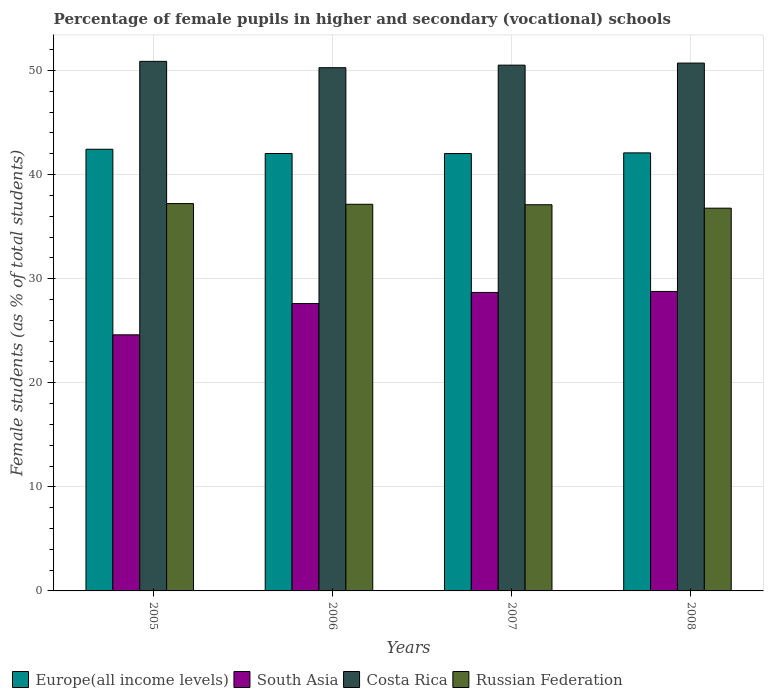How many different coloured bars are there?
Your answer should be very brief. 4. How many groups of bars are there?
Your answer should be very brief. 4. How many bars are there on the 4th tick from the left?
Offer a very short reply. 4. What is the label of the 1st group of bars from the left?
Provide a short and direct response. 2005. In how many cases, is the number of bars for a given year not equal to the number of legend labels?
Keep it short and to the point. 0. What is the percentage of female pupils in higher and secondary schools in Russian Federation in 2007?
Keep it short and to the point. 37.1. Across all years, what is the maximum percentage of female pupils in higher and secondary schools in Europe(all income levels)?
Your answer should be very brief. 42.43. Across all years, what is the minimum percentage of female pupils in higher and secondary schools in Costa Rica?
Offer a very short reply. 50.27. What is the total percentage of female pupils in higher and secondary schools in South Asia in the graph?
Ensure brevity in your answer.  109.66. What is the difference between the percentage of female pupils in higher and secondary schools in Costa Rica in 2005 and that in 2008?
Your response must be concise. 0.17. What is the difference between the percentage of female pupils in higher and secondary schools in Europe(all income levels) in 2007 and the percentage of female pupils in higher and secondary schools in Russian Federation in 2005?
Offer a terse response. 4.81. What is the average percentage of female pupils in higher and secondary schools in Costa Rica per year?
Give a very brief answer. 50.59. In the year 2006, what is the difference between the percentage of female pupils in higher and secondary schools in Russian Federation and percentage of female pupils in higher and secondary schools in South Asia?
Make the answer very short. 9.54. In how many years, is the percentage of female pupils in higher and secondary schools in Europe(all income levels) greater than 6 %?
Your response must be concise. 4. What is the ratio of the percentage of female pupils in higher and secondary schools in Russian Federation in 2005 to that in 2006?
Provide a short and direct response. 1. What is the difference between the highest and the second highest percentage of female pupils in higher and secondary schools in South Asia?
Provide a succinct answer. 0.1. What is the difference between the highest and the lowest percentage of female pupils in higher and secondary schools in Costa Rica?
Make the answer very short. 0.61. In how many years, is the percentage of female pupils in higher and secondary schools in Europe(all income levels) greater than the average percentage of female pupils in higher and secondary schools in Europe(all income levels) taken over all years?
Your response must be concise. 1. Is it the case that in every year, the sum of the percentage of female pupils in higher and secondary schools in Russian Federation and percentage of female pupils in higher and secondary schools in Europe(all income levels) is greater than the sum of percentage of female pupils in higher and secondary schools in South Asia and percentage of female pupils in higher and secondary schools in Costa Rica?
Ensure brevity in your answer.  Yes. What does the 1st bar from the right in 2005 represents?
Keep it short and to the point. Russian Federation. Is it the case that in every year, the sum of the percentage of female pupils in higher and secondary schools in Europe(all income levels) and percentage of female pupils in higher and secondary schools in Russian Federation is greater than the percentage of female pupils in higher and secondary schools in Costa Rica?
Offer a very short reply. Yes. How many bars are there?
Offer a terse response. 16. Are all the bars in the graph horizontal?
Offer a terse response. No. How many years are there in the graph?
Ensure brevity in your answer.  4. What is the difference between two consecutive major ticks on the Y-axis?
Provide a succinct answer. 10. Are the values on the major ticks of Y-axis written in scientific E-notation?
Make the answer very short. No. Does the graph contain any zero values?
Your answer should be compact. No. How are the legend labels stacked?
Make the answer very short. Horizontal. What is the title of the graph?
Provide a short and direct response. Percentage of female pupils in higher and secondary (vocational) schools. What is the label or title of the X-axis?
Your response must be concise. Years. What is the label or title of the Y-axis?
Offer a very short reply. Female students (as % of total students). What is the Female students (as % of total students) of Europe(all income levels) in 2005?
Offer a very short reply. 42.43. What is the Female students (as % of total students) in South Asia in 2005?
Give a very brief answer. 24.6. What is the Female students (as % of total students) in Costa Rica in 2005?
Keep it short and to the point. 50.88. What is the Female students (as % of total students) of Russian Federation in 2005?
Ensure brevity in your answer.  37.21. What is the Female students (as % of total students) in Europe(all income levels) in 2006?
Your answer should be compact. 42.03. What is the Female students (as % of total students) of South Asia in 2006?
Give a very brief answer. 27.61. What is the Female students (as % of total students) in Costa Rica in 2006?
Your answer should be very brief. 50.27. What is the Female students (as % of total students) in Russian Federation in 2006?
Your answer should be very brief. 37.15. What is the Female students (as % of total students) in Europe(all income levels) in 2007?
Your answer should be very brief. 42.02. What is the Female students (as % of total students) in South Asia in 2007?
Provide a short and direct response. 28.68. What is the Female students (as % of total students) of Costa Rica in 2007?
Make the answer very short. 50.52. What is the Female students (as % of total students) of Russian Federation in 2007?
Offer a terse response. 37.1. What is the Female students (as % of total students) in Europe(all income levels) in 2008?
Your response must be concise. 42.09. What is the Female students (as % of total students) of South Asia in 2008?
Your answer should be very brief. 28.77. What is the Female students (as % of total students) of Costa Rica in 2008?
Provide a short and direct response. 50.71. What is the Female students (as % of total students) in Russian Federation in 2008?
Provide a short and direct response. 36.77. Across all years, what is the maximum Female students (as % of total students) in Europe(all income levels)?
Offer a terse response. 42.43. Across all years, what is the maximum Female students (as % of total students) in South Asia?
Your answer should be very brief. 28.77. Across all years, what is the maximum Female students (as % of total students) in Costa Rica?
Your answer should be compact. 50.88. Across all years, what is the maximum Female students (as % of total students) of Russian Federation?
Your answer should be very brief. 37.21. Across all years, what is the minimum Female students (as % of total students) of Europe(all income levels)?
Provide a short and direct response. 42.02. Across all years, what is the minimum Female students (as % of total students) of South Asia?
Offer a terse response. 24.6. Across all years, what is the minimum Female students (as % of total students) in Costa Rica?
Make the answer very short. 50.27. Across all years, what is the minimum Female students (as % of total students) of Russian Federation?
Provide a succinct answer. 36.77. What is the total Female students (as % of total students) in Europe(all income levels) in the graph?
Give a very brief answer. 168.57. What is the total Female students (as % of total students) of South Asia in the graph?
Your answer should be compact. 109.66. What is the total Female students (as % of total students) in Costa Rica in the graph?
Make the answer very short. 202.38. What is the total Female students (as % of total students) in Russian Federation in the graph?
Make the answer very short. 148.24. What is the difference between the Female students (as % of total students) of Europe(all income levels) in 2005 and that in 2006?
Your answer should be compact. 0.41. What is the difference between the Female students (as % of total students) of South Asia in 2005 and that in 2006?
Your response must be concise. -3.01. What is the difference between the Female students (as % of total students) in Costa Rica in 2005 and that in 2006?
Provide a succinct answer. 0.61. What is the difference between the Female students (as % of total students) in Russian Federation in 2005 and that in 2006?
Your answer should be compact. 0.07. What is the difference between the Female students (as % of total students) in Europe(all income levels) in 2005 and that in 2007?
Give a very brief answer. 0.41. What is the difference between the Female students (as % of total students) in South Asia in 2005 and that in 2007?
Offer a terse response. -4.07. What is the difference between the Female students (as % of total students) in Costa Rica in 2005 and that in 2007?
Your response must be concise. 0.36. What is the difference between the Female students (as % of total students) in Russian Federation in 2005 and that in 2007?
Your answer should be compact. 0.11. What is the difference between the Female students (as % of total students) in Europe(all income levels) in 2005 and that in 2008?
Your answer should be compact. 0.35. What is the difference between the Female students (as % of total students) of South Asia in 2005 and that in 2008?
Give a very brief answer. -4.17. What is the difference between the Female students (as % of total students) of Costa Rica in 2005 and that in 2008?
Your answer should be compact. 0.17. What is the difference between the Female students (as % of total students) in Russian Federation in 2005 and that in 2008?
Ensure brevity in your answer.  0.44. What is the difference between the Female students (as % of total students) in Europe(all income levels) in 2006 and that in 2007?
Offer a terse response. 0. What is the difference between the Female students (as % of total students) in South Asia in 2006 and that in 2007?
Your response must be concise. -1.07. What is the difference between the Female students (as % of total students) of Costa Rica in 2006 and that in 2007?
Offer a terse response. -0.25. What is the difference between the Female students (as % of total students) of Russian Federation in 2006 and that in 2007?
Ensure brevity in your answer.  0.05. What is the difference between the Female students (as % of total students) of Europe(all income levels) in 2006 and that in 2008?
Ensure brevity in your answer.  -0.06. What is the difference between the Female students (as % of total students) of South Asia in 2006 and that in 2008?
Offer a terse response. -1.16. What is the difference between the Female students (as % of total students) of Costa Rica in 2006 and that in 2008?
Offer a terse response. -0.44. What is the difference between the Female students (as % of total students) in Russian Federation in 2006 and that in 2008?
Your answer should be very brief. 0.38. What is the difference between the Female students (as % of total students) in Europe(all income levels) in 2007 and that in 2008?
Provide a short and direct response. -0.06. What is the difference between the Female students (as % of total students) in South Asia in 2007 and that in 2008?
Provide a succinct answer. -0.1. What is the difference between the Female students (as % of total students) of Costa Rica in 2007 and that in 2008?
Your answer should be very brief. -0.2. What is the difference between the Female students (as % of total students) of Russian Federation in 2007 and that in 2008?
Provide a succinct answer. 0.33. What is the difference between the Female students (as % of total students) in Europe(all income levels) in 2005 and the Female students (as % of total students) in South Asia in 2006?
Offer a terse response. 14.82. What is the difference between the Female students (as % of total students) of Europe(all income levels) in 2005 and the Female students (as % of total students) of Costa Rica in 2006?
Make the answer very short. -7.84. What is the difference between the Female students (as % of total students) of Europe(all income levels) in 2005 and the Female students (as % of total students) of Russian Federation in 2006?
Keep it short and to the point. 5.29. What is the difference between the Female students (as % of total students) of South Asia in 2005 and the Female students (as % of total students) of Costa Rica in 2006?
Give a very brief answer. -25.66. What is the difference between the Female students (as % of total students) in South Asia in 2005 and the Female students (as % of total students) in Russian Federation in 2006?
Ensure brevity in your answer.  -12.54. What is the difference between the Female students (as % of total students) of Costa Rica in 2005 and the Female students (as % of total students) of Russian Federation in 2006?
Ensure brevity in your answer.  13.73. What is the difference between the Female students (as % of total students) in Europe(all income levels) in 2005 and the Female students (as % of total students) in South Asia in 2007?
Provide a succinct answer. 13.76. What is the difference between the Female students (as % of total students) of Europe(all income levels) in 2005 and the Female students (as % of total students) of Costa Rica in 2007?
Keep it short and to the point. -8.08. What is the difference between the Female students (as % of total students) of Europe(all income levels) in 2005 and the Female students (as % of total students) of Russian Federation in 2007?
Provide a short and direct response. 5.33. What is the difference between the Female students (as % of total students) of South Asia in 2005 and the Female students (as % of total students) of Costa Rica in 2007?
Offer a very short reply. -25.91. What is the difference between the Female students (as % of total students) of South Asia in 2005 and the Female students (as % of total students) of Russian Federation in 2007?
Provide a succinct answer. -12.5. What is the difference between the Female students (as % of total students) of Costa Rica in 2005 and the Female students (as % of total students) of Russian Federation in 2007?
Your answer should be compact. 13.78. What is the difference between the Female students (as % of total students) in Europe(all income levels) in 2005 and the Female students (as % of total students) in South Asia in 2008?
Provide a short and direct response. 13.66. What is the difference between the Female students (as % of total students) in Europe(all income levels) in 2005 and the Female students (as % of total students) in Costa Rica in 2008?
Your answer should be very brief. -8.28. What is the difference between the Female students (as % of total students) of Europe(all income levels) in 2005 and the Female students (as % of total students) of Russian Federation in 2008?
Make the answer very short. 5.66. What is the difference between the Female students (as % of total students) in South Asia in 2005 and the Female students (as % of total students) in Costa Rica in 2008?
Provide a succinct answer. -26.11. What is the difference between the Female students (as % of total students) of South Asia in 2005 and the Female students (as % of total students) of Russian Federation in 2008?
Your answer should be compact. -12.17. What is the difference between the Female students (as % of total students) in Costa Rica in 2005 and the Female students (as % of total students) in Russian Federation in 2008?
Offer a very short reply. 14.11. What is the difference between the Female students (as % of total students) in Europe(all income levels) in 2006 and the Female students (as % of total students) in South Asia in 2007?
Keep it short and to the point. 13.35. What is the difference between the Female students (as % of total students) in Europe(all income levels) in 2006 and the Female students (as % of total students) in Costa Rica in 2007?
Give a very brief answer. -8.49. What is the difference between the Female students (as % of total students) of Europe(all income levels) in 2006 and the Female students (as % of total students) of Russian Federation in 2007?
Ensure brevity in your answer.  4.92. What is the difference between the Female students (as % of total students) of South Asia in 2006 and the Female students (as % of total students) of Costa Rica in 2007?
Keep it short and to the point. -22.91. What is the difference between the Female students (as % of total students) of South Asia in 2006 and the Female students (as % of total students) of Russian Federation in 2007?
Ensure brevity in your answer.  -9.49. What is the difference between the Female students (as % of total students) in Costa Rica in 2006 and the Female students (as % of total students) in Russian Federation in 2007?
Provide a succinct answer. 13.17. What is the difference between the Female students (as % of total students) in Europe(all income levels) in 2006 and the Female students (as % of total students) in South Asia in 2008?
Your response must be concise. 13.25. What is the difference between the Female students (as % of total students) in Europe(all income levels) in 2006 and the Female students (as % of total students) in Costa Rica in 2008?
Keep it short and to the point. -8.69. What is the difference between the Female students (as % of total students) in Europe(all income levels) in 2006 and the Female students (as % of total students) in Russian Federation in 2008?
Give a very brief answer. 5.25. What is the difference between the Female students (as % of total students) in South Asia in 2006 and the Female students (as % of total students) in Costa Rica in 2008?
Provide a short and direct response. -23.1. What is the difference between the Female students (as % of total students) of South Asia in 2006 and the Female students (as % of total students) of Russian Federation in 2008?
Provide a succinct answer. -9.16. What is the difference between the Female students (as % of total students) in Costa Rica in 2006 and the Female students (as % of total students) in Russian Federation in 2008?
Your response must be concise. 13.5. What is the difference between the Female students (as % of total students) in Europe(all income levels) in 2007 and the Female students (as % of total students) in South Asia in 2008?
Offer a very short reply. 13.25. What is the difference between the Female students (as % of total students) in Europe(all income levels) in 2007 and the Female students (as % of total students) in Costa Rica in 2008?
Make the answer very short. -8.69. What is the difference between the Female students (as % of total students) of Europe(all income levels) in 2007 and the Female students (as % of total students) of Russian Federation in 2008?
Your response must be concise. 5.25. What is the difference between the Female students (as % of total students) in South Asia in 2007 and the Female students (as % of total students) in Costa Rica in 2008?
Give a very brief answer. -22.04. What is the difference between the Female students (as % of total students) of South Asia in 2007 and the Female students (as % of total students) of Russian Federation in 2008?
Offer a terse response. -8.1. What is the difference between the Female students (as % of total students) in Costa Rica in 2007 and the Female students (as % of total students) in Russian Federation in 2008?
Ensure brevity in your answer.  13.74. What is the average Female students (as % of total students) in Europe(all income levels) per year?
Give a very brief answer. 42.14. What is the average Female students (as % of total students) of South Asia per year?
Provide a succinct answer. 27.42. What is the average Female students (as % of total students) of Costa Rica per year?
Your answer should be compact. 50.59. What is the average Female students (as % of total students) of Russian Federation per year?
Your answer should be compact. 37.06. In the year 2005, what is the difference between the Female students (as % of total students) in Europe(all income levels) and Female students (as % of total students) in South Asia?
Your answer should be very brief. 17.83. In the year 2005, what is the difference between the Female students (as % of total students) of Europe(all income levels) and Female students (as % of total students) of Costa Rica?
Ensure brevity in your answer.  -8.45. In the year 2005, what is the difference between the Female students (as % of total students) in Europe(all income levels) and Female students (as % of total students) in Russian Federation?
Ensure brevity in your answer.  5.22. In the year 2005, what is the difference between the Female students (as % of total students) in South Asia and Female students (as % of total students) in Costa Rica?
Give a very brief answer. -26.27. In the year 2005, what is the difference between the Female students (as % of total students) of South Asia and Female students (as % of total students) of Russian Federation?
Your response must be concise. -12.61. In the year 2005, what is the difference between the Female students (as % of total students) of Costa Rica and Female students (as % of total students) of Russian Federation?
Keep it short and to the point. 13.66. In the year 2006, what is the difference between the Female students (as % of total students) of Europe(all income levels) and Female students (as % of total students) of South Asia?
Your answer should be very brief. 14.42. In the year 2006, what is the difference between the Female students (as % of total students) in Europe(all income levels) and Female students (as % of total students) in Costa Rica?
Offer a very short reply. -8.24. In the year 2006, what is the difference between the Female students (as % of total students) of Europe(all income levels) and Female students (as % of total students) of Russian Federation?
Give a very brief answer. 4.88. In the year 2006, what is the difference between the Female students (as % of total students) of South Asia and Female students (as % of total students) of Costa Rica?
Offer a very short reply. -22.66. In the year 2006, what is the difference between the Female students (as % of total students) in South Asia and Female students (as % of total students) in Russian Federation?
Your answer should be very brief. -9.54. In the year 2006, what is the difference between the Female students (as % of total students) in Costa Rica and Female students (as % of total students) in Russian Federation?
Provide a short and direct response. 13.12. In the year 2007, what is the difference between the Female students (as % of total students) in Europe(all income levels) and Female students (as % of total students) in South Asia?
Provide a succinct answer. 13.35. In the year 2007, what is the difference between the Female students (as % of total students) in Europe(all income levels) and Female students (as % of total students) in Costa Rica?
Offer a terse response. -8.49. In the year 2007, what is the difference between the Female students (as % of total students) in Europe(all income levels) and Female students (as % of total students) in Russian Federation?
Provide a succinct answer. 4.92. In the year 2007, what is the difference between the Female students (as % of total students) of South Asia and Female students (as % of total students) of Costa Rica?
Your response must be concise. -21.84. In the year 2007, what is the difference between the Female students (as % of total students) in South Asia and Female students (as % of total students) in Russian Federation?
Offer a terse response. -8.43. In the year 2007, what is the difference between the Female students (as % of total students) of Costa Rica and Female students (as % of total students) of Russian Federation?
Provide a short and direct response. 13.41. In the year 2008, what is the difference between the Female students (as % of total students) of Europe(all income levels) and Female students (as % of total students) of South Asia?
Your response must be concise. 13.31. In the year 2008, what is the difference between the Female students (as % of total students) in Europe(all income levels) and Female students (as % of total students) in Costa Rica?
Keep it short and to the point. -8.63. In the year 2008, what is the difference between the Female students (as % of total students) of Europe(all income levels) and Female students (as % of total students) of Russian Federation?
Give a very brief answer. 5.31. In the year 2008, what is the difference between the Female students (as % of total students) in South Asia and Female students (as % of total students) in Costa Rica?
Keep it short and to the point. -21.94. In the year 2008, what is the difference between the Female students (as % of total students) of South Asia and Female students (as % of total students) of Russian Federation?
Offer a terse response. -8. In the year 2008, what is the difference between the Female students (as % of total students) of Costa Rica and Female students (as % of total students) of Russian Federation?
Make the answer very short. 13.94. What is the ratio of the Female students (as % of total students) of Europe(all income levels) in 2005 to that in 2006?
Your answer should be very brief. 1.01. What is the ratio of the Female students (as % of total students) in South Asia in 2005 to that in 2006?
Your response must be concise. 0.89. What is the ratio of the Female students (as % of total students) of Costa Rica in 2005 to that in 2006?
Ensure brevity in your answer.  1.01. What is the ratio of the Female students (as % of total students) in Russian Federation in 2005 to that in 2006?
Your answer should be very brief. 1. What is the ratio of the Female students (as % of total students) of Europe(all income levels) in 2005 to that in 2007?
Offer a terse response. 1.01. What is the ratio of the Female students (as % of total students) in South Asia in 2005 to that in 2007?
Offer a terse response. 0.86. What is the ratio of the Female students (as % of total students) of Russian Federation in 2005 to that in 2007?
Your answer should be compact. 1. What is the ratio of the Female students (as % of total students) in Europe(all income levels) in 2005 to that in 2008?
Your response must be concise. 1.01. What is the ratio of the Female students (as % of total students) of South Asia in 2005 to that in 2008?
Provide a succinct answer. 0.86. What is the ratio of the Female students (as % of total students) of Costa Rica in 2005 to that in 2008?
Keep it short and to the point. 1. What is the ratio of the Female students (as % of total students) of Europe(all income levels) in 2006 to that in 2007?
Make the answer very short. 1. What is the ratio of the Female students (as % of total students) in South Asia in 2006 to that in 2007?
Provide a short and direct response. 0.96. What is the ratio of the Female students (as % of total students) of Russian Federation in 2006 to that in 2007?
Provide a short and direct response. 1. What is the ratio of the Female students (as % of total students) in South Asia in 2006 to that in 2008?
Your response must be concise. 0.96. What is the ratio of the Female students (as % of total students) in Russian Federation in 2006 to that in 2008?
Keep it short and to the point. 1.01. What is the ratio of the Female students (as % of total students) of Europe(all income levels) in 2007 to that in 2008?
Provide a short and direct response. 1. What is the ratio of the Female students (as % of total students) in South Asia in 2007 to that in 2008?
Offer a very short reply. 1. What is the difference between the highest and the second highest Female students (as % of total students) in Europe(all income levels)?
Provide a short and direct response. 0.35. What is the difference between the highest and the second highest Female students (as % of total students) of South Asia?
Offer a terse response. 0.1. What is the difference between the highest and the second highest Female students (as % of total students) of Costa Rica?
Your response must be concise. 0.17. What is the difference between the highest and the second highest Female students (as % of total students) of Russian Federation?
Give a very brief answer. 0.07. What is the difference between the highest and the lowest Female students (as % of total students) of Europe(all income levels)?
Offer a very short reply. 0.41. What is the difference between the highest and the lowest Female students (as % of total students) of South Asia?
Offer a very short reply. 4.17. What is the difference between the highest and the lowest Female students (as % of total students) in Costa Rica?
Provide a succinct answer. 0.61. What is the difference between the highest and the lowest Female students (as % of total students) in Russian Federation?
Give a very brief answer. 0.44. 